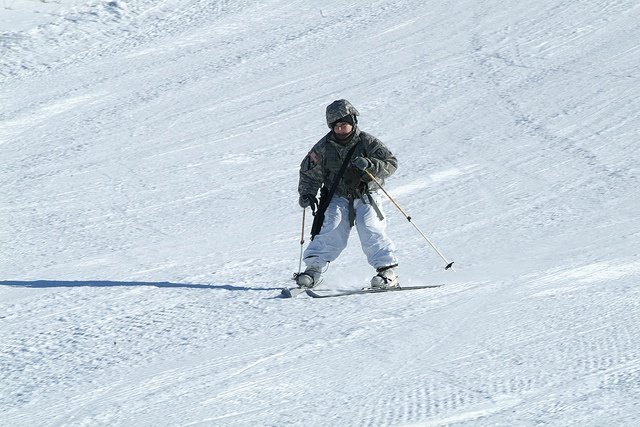Describe the objects in this image and their specific colors. I can see people in white, black, gray, and darkgray tones in this image. 